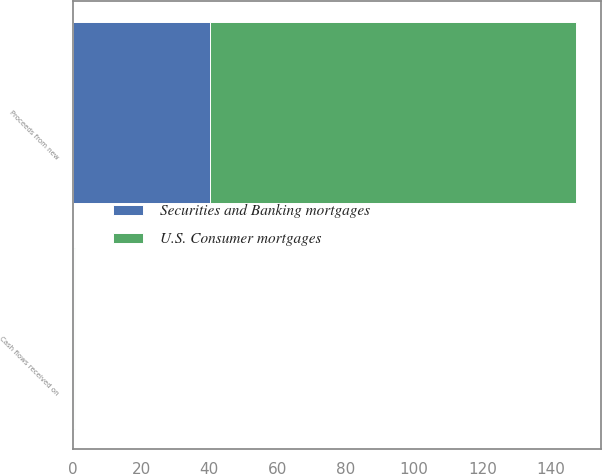<chart> <loc_0><loc_0><loc_500><loc_500><stacked_bar_chart><ecel><fcel>Proceeds from new<fcel>Cash flows received on<nl><fcel>U.S. Consumer mortgages<fcel>107.2<fcel>0.3<nl><fcel>Securities and Banking mortgages<fcel>40.1<fcel>0.3<nl></chart> 